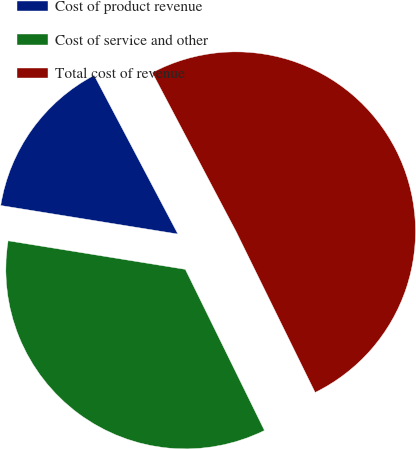Convert chart to OTSL. <chart><loc_0><loc_0><loc_500><loc_500><pie_chart><fcel>Cost of product revenue<fcel>Cost of service and other<fcel>Total cost of revenue<nl><fcel>14.73%<fcel>34.81%<fcel>50.46%<nl></chart> 